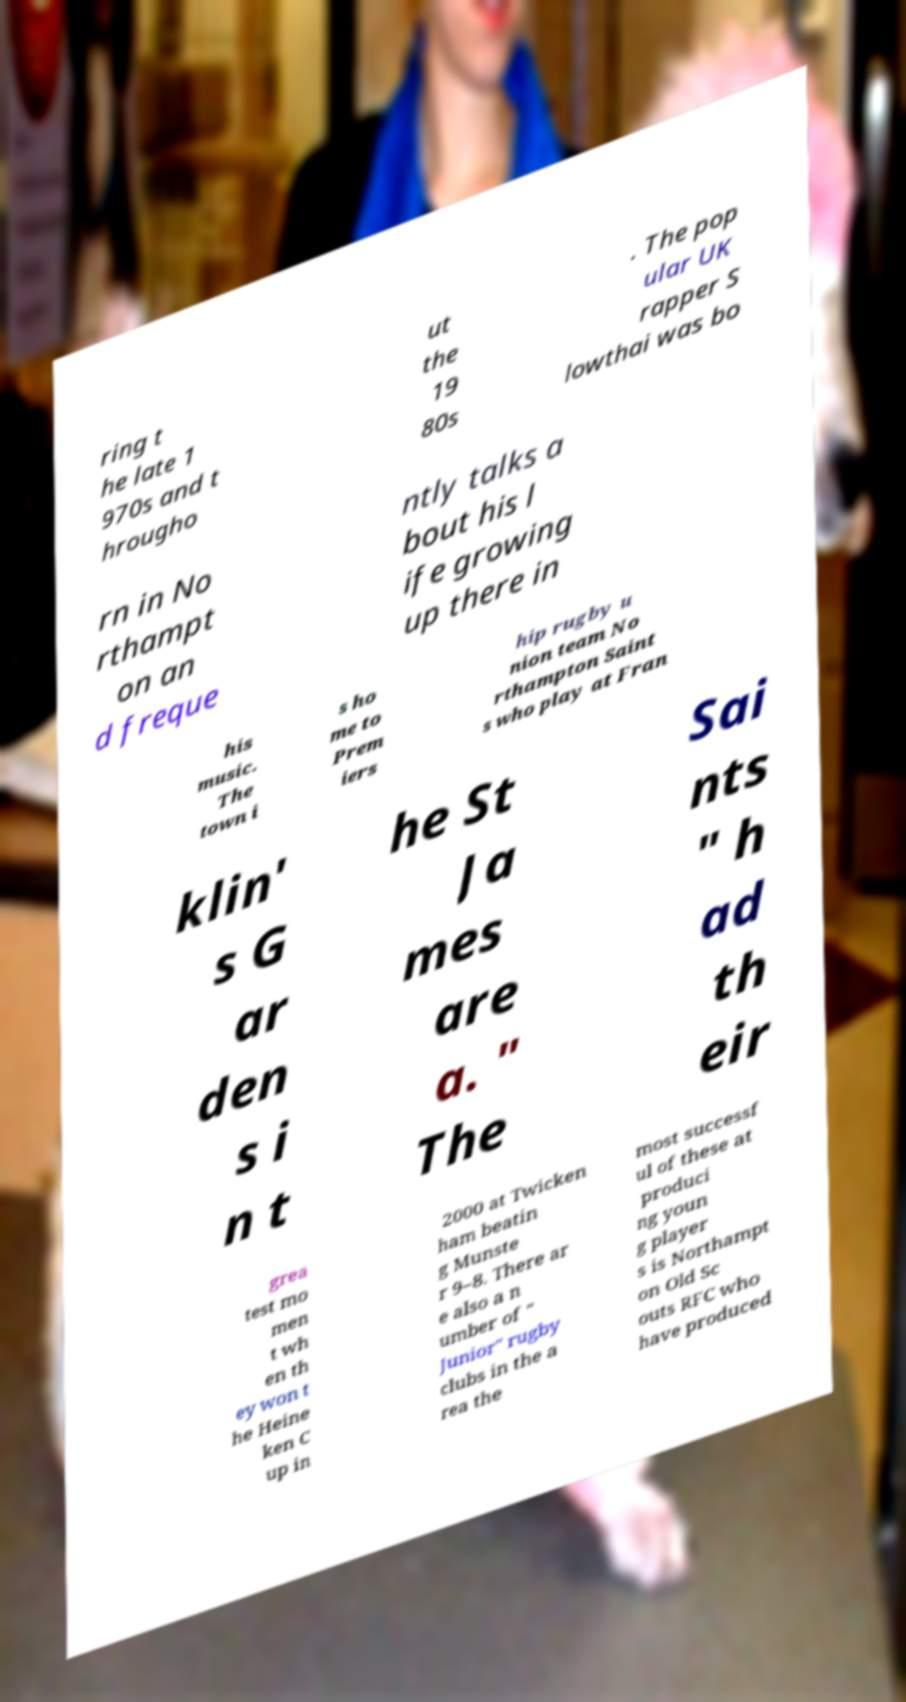Could you assist in decoding the text presented in this image and type it out clearly? ring t he late 1 970s and t hrougho ut the 19 80s . The pop ular UK rapper S lowthai was bo rn in No rthampt on an d freque ntly talks a bout his l ife growing up there in his music. The town i s ho me to Prem iers hip rugby u nion team No rthampton Saint s who play at Fran klin' s G ar den s i n t he St Ja mes are a. " The Sai nts " h ad th eir grea test mo men t wh en th ey won t he Heine ken C up in 2000 at Twicken ham beatin g Munste r 9–8. There ar e also a n umber of " Junior" rugby clubs in the a rea the most successf ul of these at produci ng youn g player s is Northampt on Old Sc outs RFC who have produced 